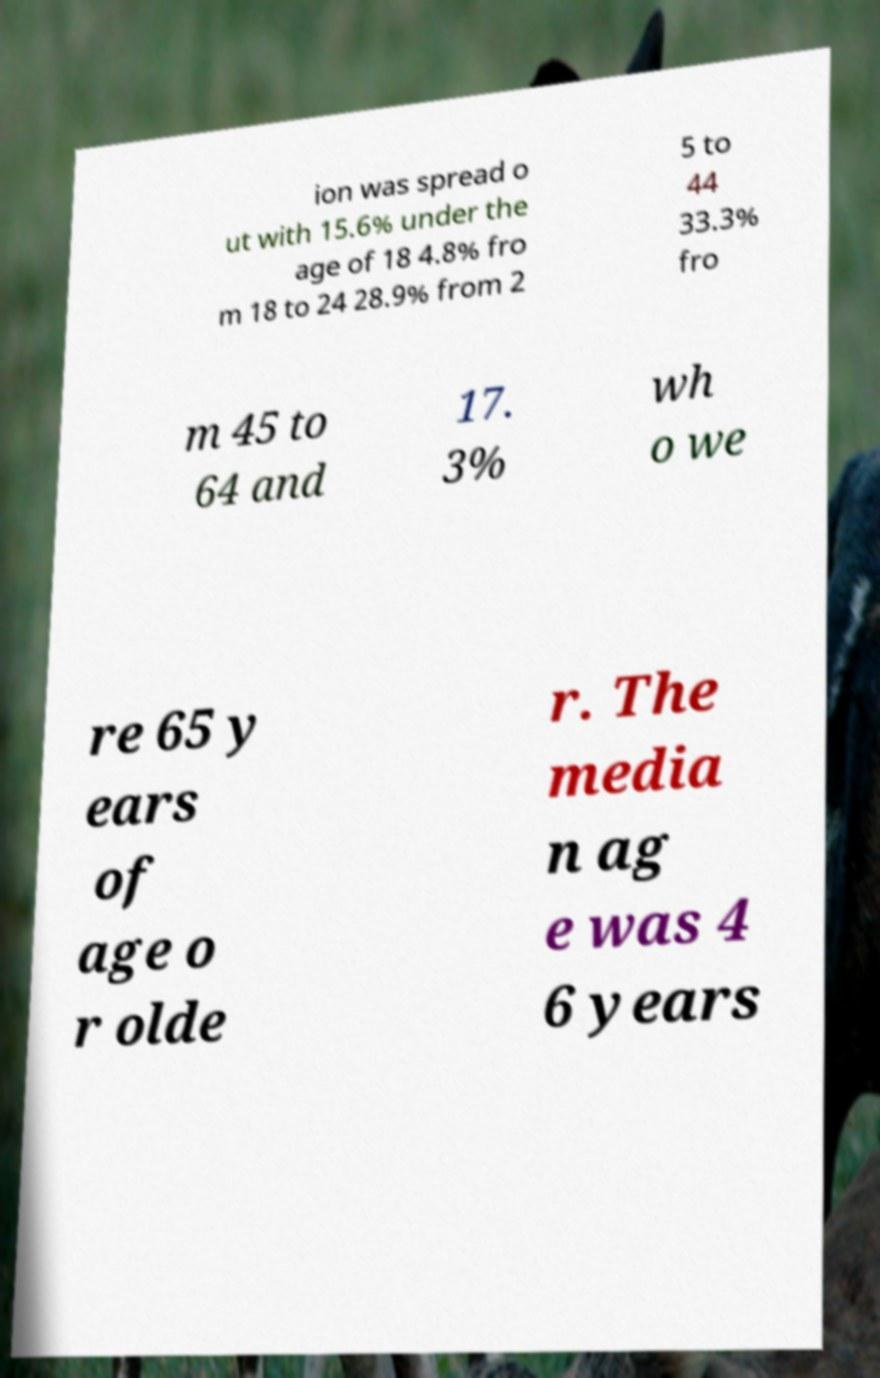There's text embedded in this image that I need extracted. Can you transcribe it verbatim? ion was spread o ut with 15.6% under the age of 18 4.8% fro m 18 to 24 28.9% from 2 5 to 44 33.3% fro m 45 to 64 and 17. 3% wh o we re 65 y ears of age o r olde r. The media n ag e was 4 6 years 